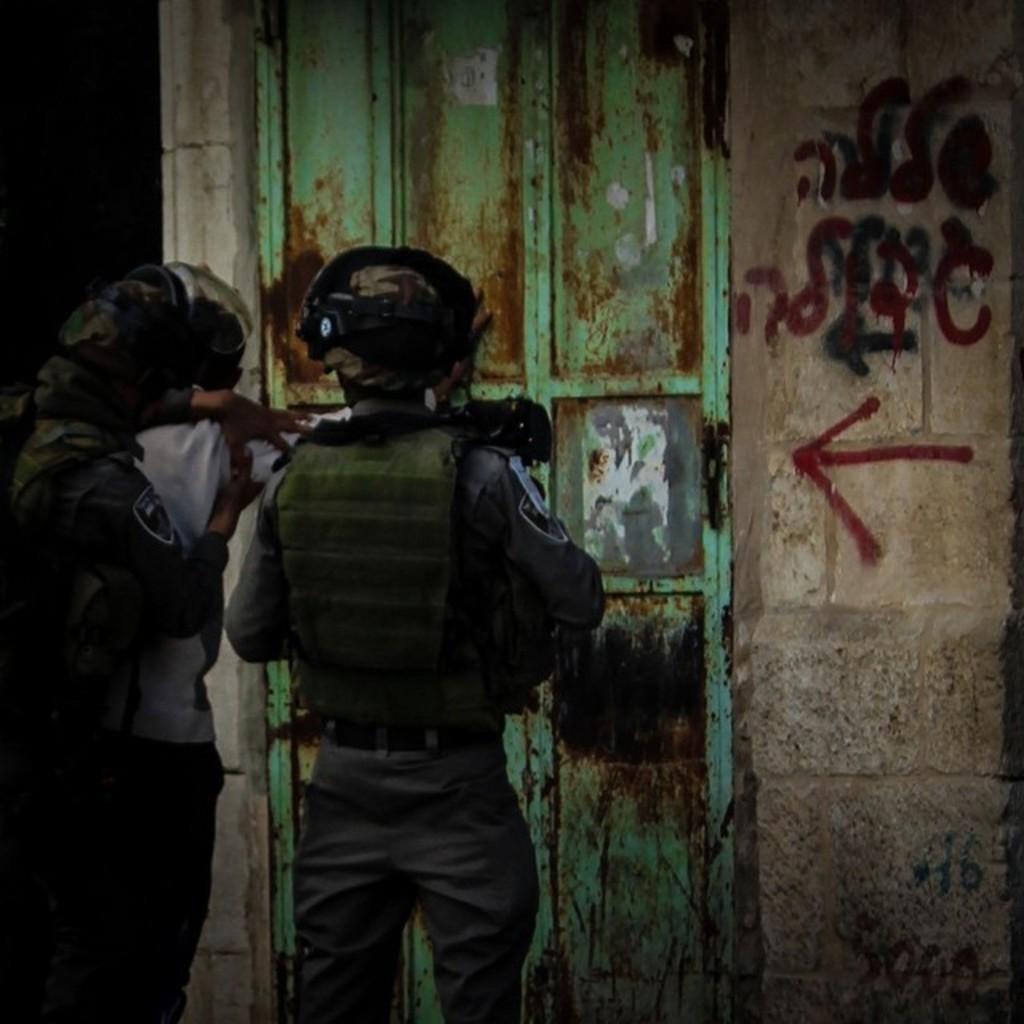Could you give a brief overview of what you see in this image? In this image we can see there are some people standing near the door ,and the background is dark. 